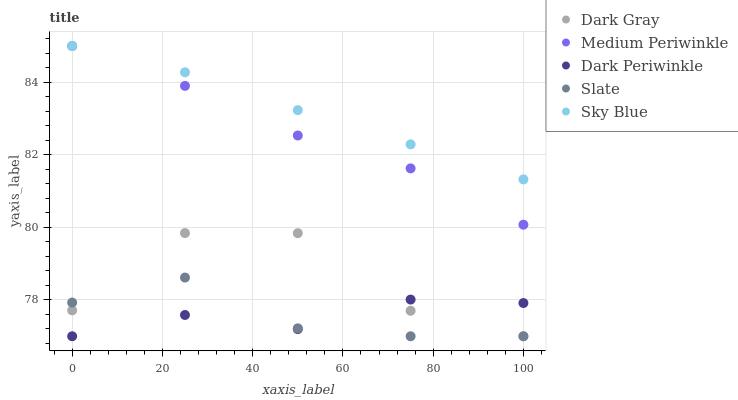Does Dark Periwinkle have the minimum area under the curve?
Answer yes or no. Yes. Does Sky Blue have the maximum area under the curve?
Answer yes or no. Yes. Does Slate have the minimum area under the curve?
Answer yes or no. No. Does Slate have the maximum area under the curve?
Answer yes or no. No. Is Sky Blue the smoothest?
Answer yes or no. Yes. Is Dark Gray the roughest?
Answer yes or no. Yes. Is Slate the smoothest?
Answer yes or no. No. Is Slate the roughest?
Answer yes or no. No. Does Dark Gray have the lowest value?
Answer yes or no. Yes. Does Sky Blue have the lowest value?
Answer yes or no. No. Does Medium Periwinkle have the highest value?
Answer yes or no. Yes. Does Slate have the highest value?
Answer yes or no. No. Is Slate less than Medium Periwinkle?
Answer yes or no. Yes. Is Sky Blue greater than Slate?
Answer yes or no. Yes. Does Medium Periwinkle intersect Sky Blue?
Answer yes or no. Yes. Is Medium Periwinkle less than Sky Blue?
Answer yes or no. No. Is Medium Periwinkle greater than Sky Blue?
Answer yes or no. No. Does Slate intersect Medium Periwinkle?
Answer yes or no. No. 